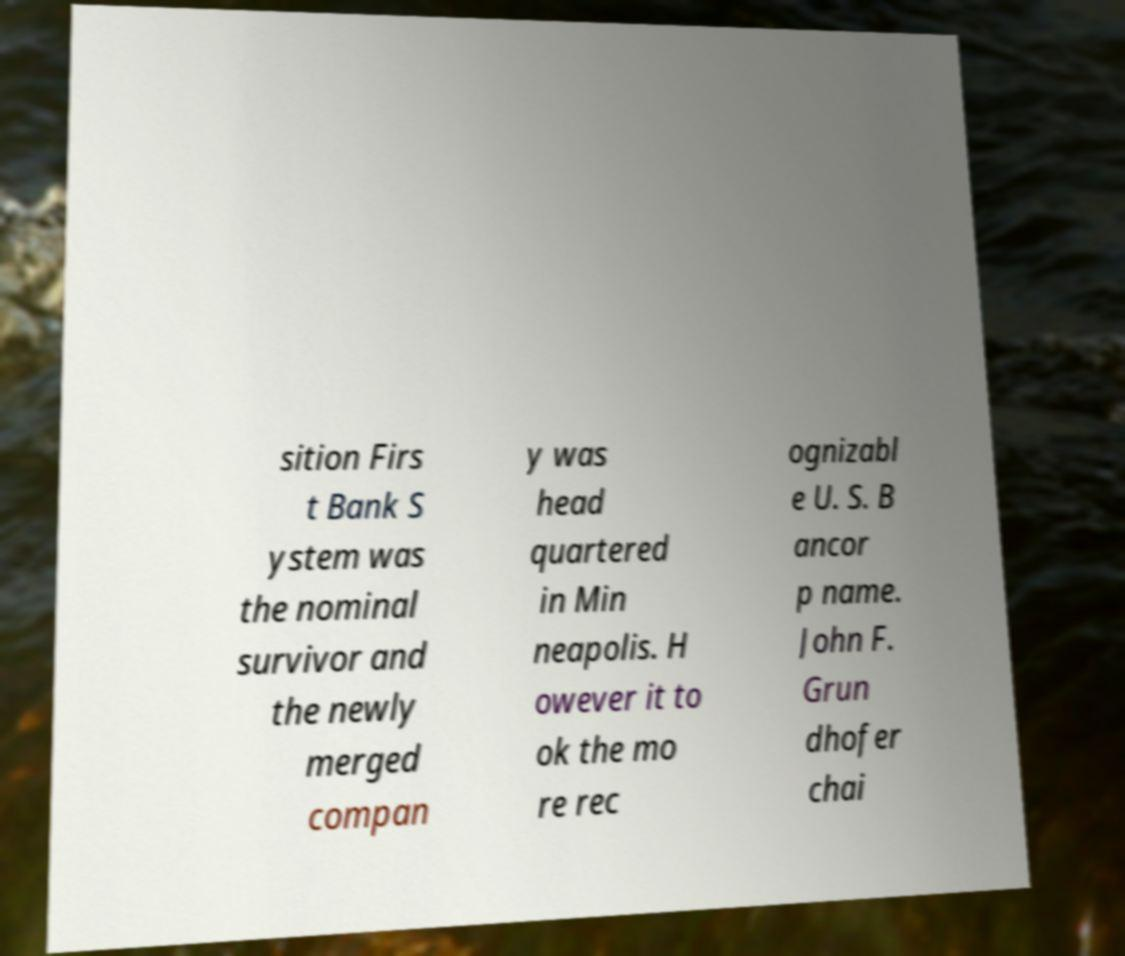I need the written content from this picture converted into text. Can you do that? sition Firs t Bank S ystem was the nominal survivor and the newly merged compan y was head quartered in Min neapolis. H owever it to ok the mo re rec ognizabl e U. S. B ancor p name. John F. Grun dhofer chai 